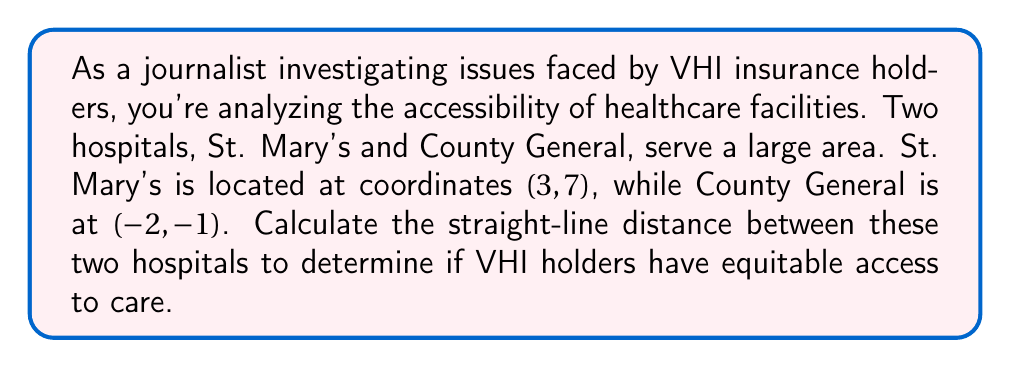What is the answer to this math problem? To solve this problem, we'll use the distance formula derived from the Pythagorean theorem:

$$d = \sqrt{(x_2 - x_1)^2 + (y_2 - y_1)^2}$$

Where $(x_1, y_1)$ are the coordinates of the first point and $(x_2, y_2)$ are the coordinates of the second point.

Step 1: Identify the coordinates
- St. Mary's: $(x_1, y_1) = (3, 7)$
- County General: $(x_2, y_2) = (-2, -1)$

Step 2: Plug the coordinates into the distance formula
$$d = \sqrt{(-2 - 3)^2 + (-1 - 7)^2}$$

Step 3: Simplify the expressions inside the parentheses
$$d = \sqrt{(-5)^2 + (-8)^2}$$

Step 4: Calculate the squares
$$d = \sqrt{25 + 64}$$

Step 5: Add the values under the square root
$$d = \sqrt{89}$$

Step 6: Simplify the square root (if possible)
In this case, $\sqrt{89}$ cannot be simplified further.

Therefore, the distance between St. Mary's and County General is $\sqrt{89}$ units.
Answer: $\sqrt{89}$ units 